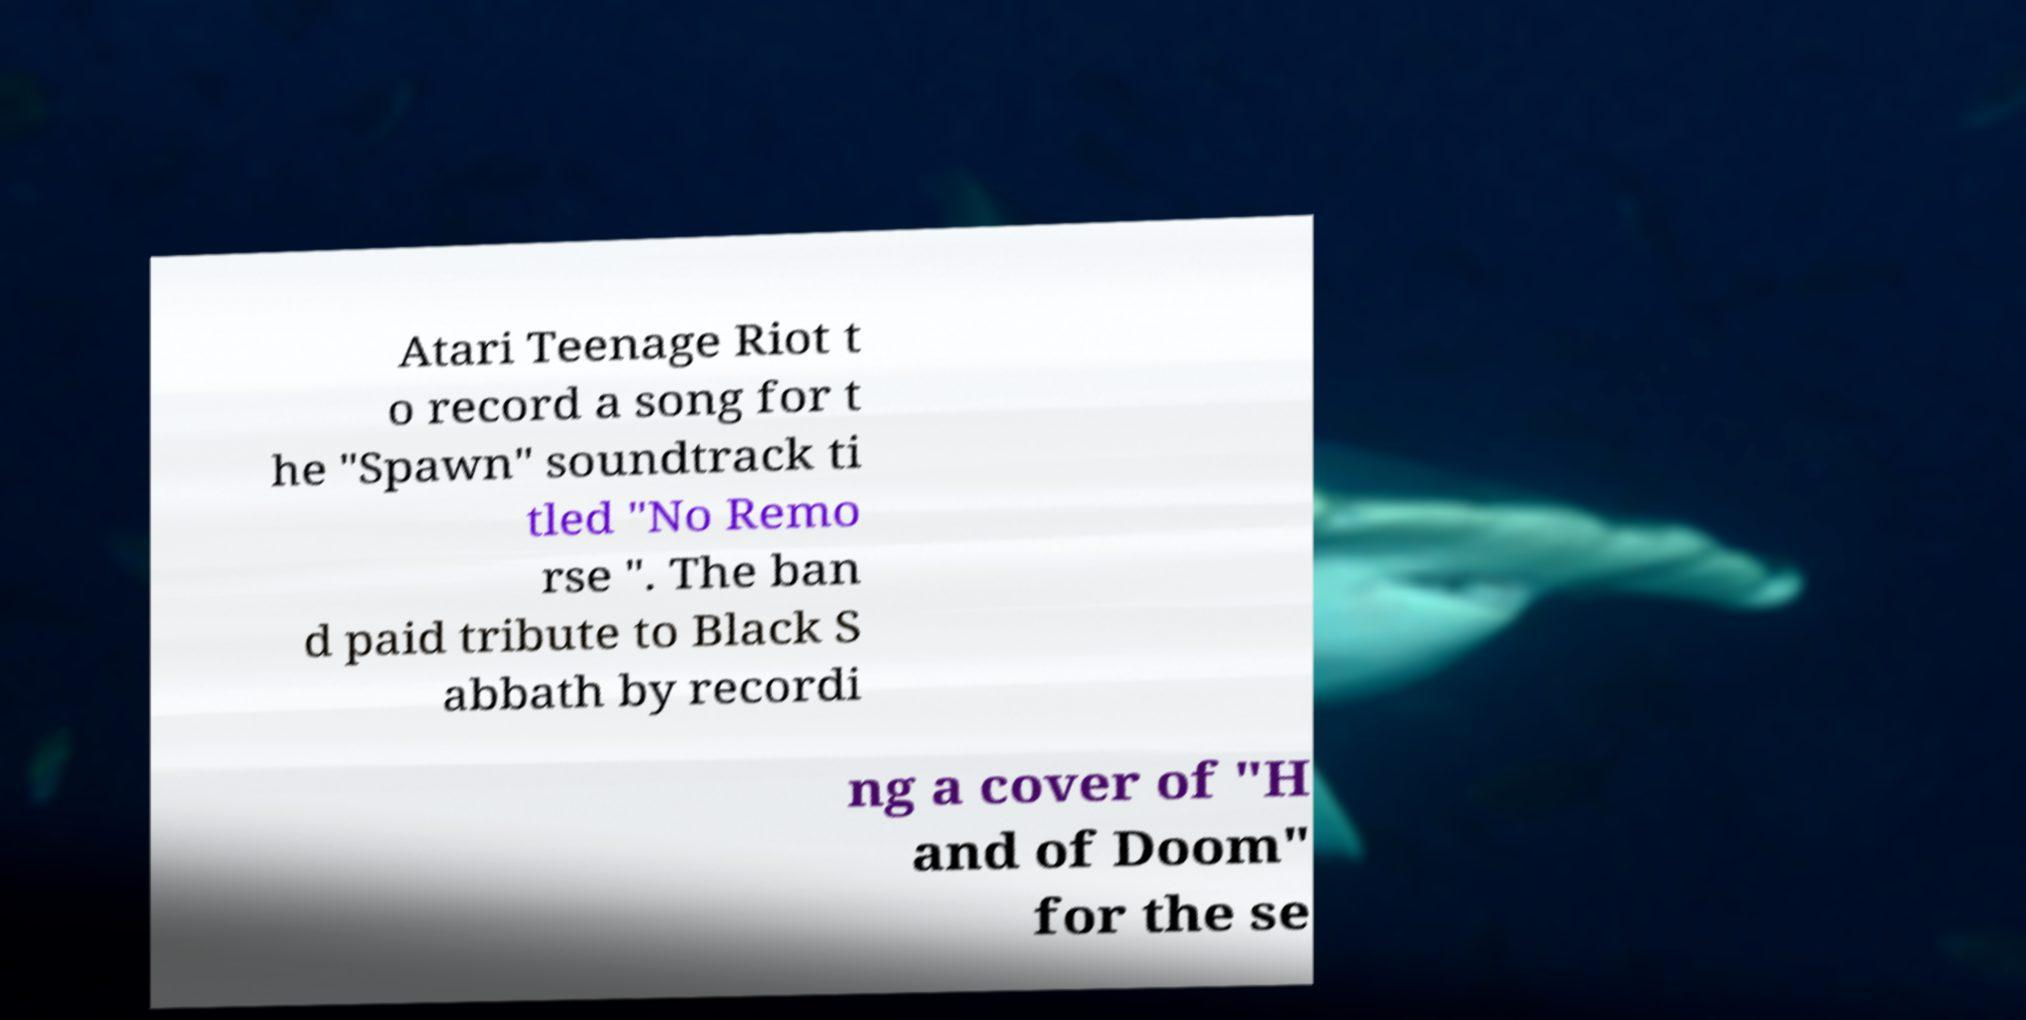Could you assist in decoding the text presented in this image and type it out clearly? Atari Teenage Riot t o record a song for t he "Spawn" soundtrack ti tled "No Remo rse ". The ban d paid tribute to Black S abbath by recordi ng a cover of "H and of Doom" for the se 